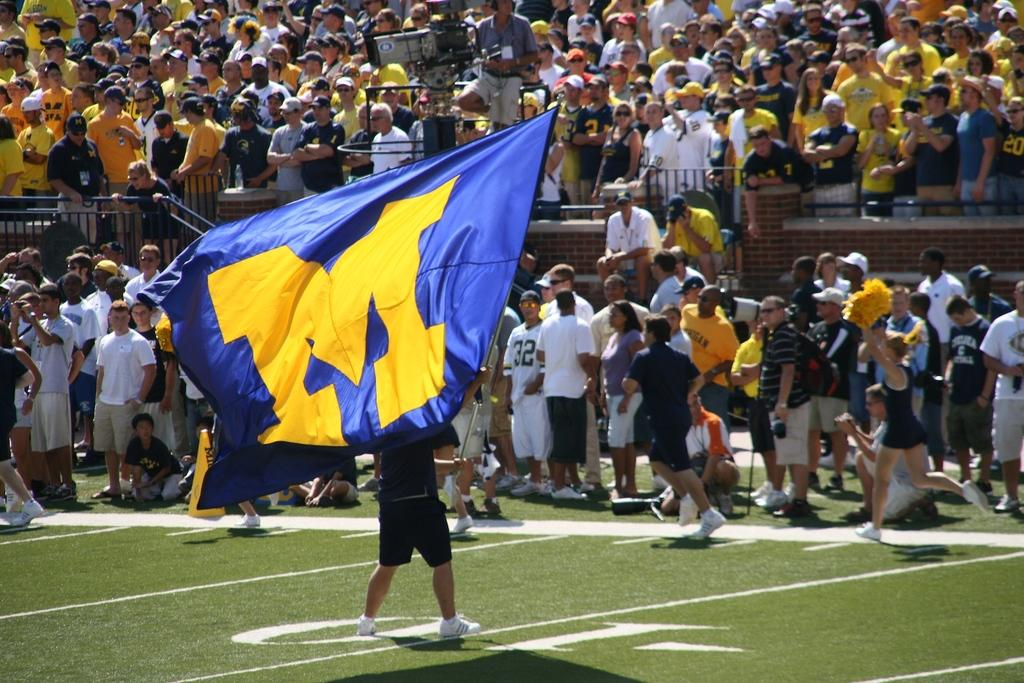<image>
Present a compact description of the photo's key features. A happy person on the pitch is running wrapped in a flag with the letter M on it. 